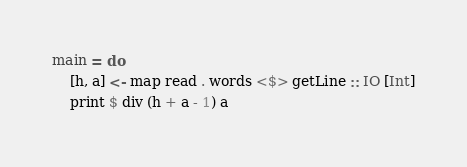Convert code to text. <code><loc_0><loc_0><loc_500><loc_500><_Haskell_>main = do
    [h, a] <- map read . words <$> getLine :: IO [Int]
    print $ div (h + a - 1) a
</code> 